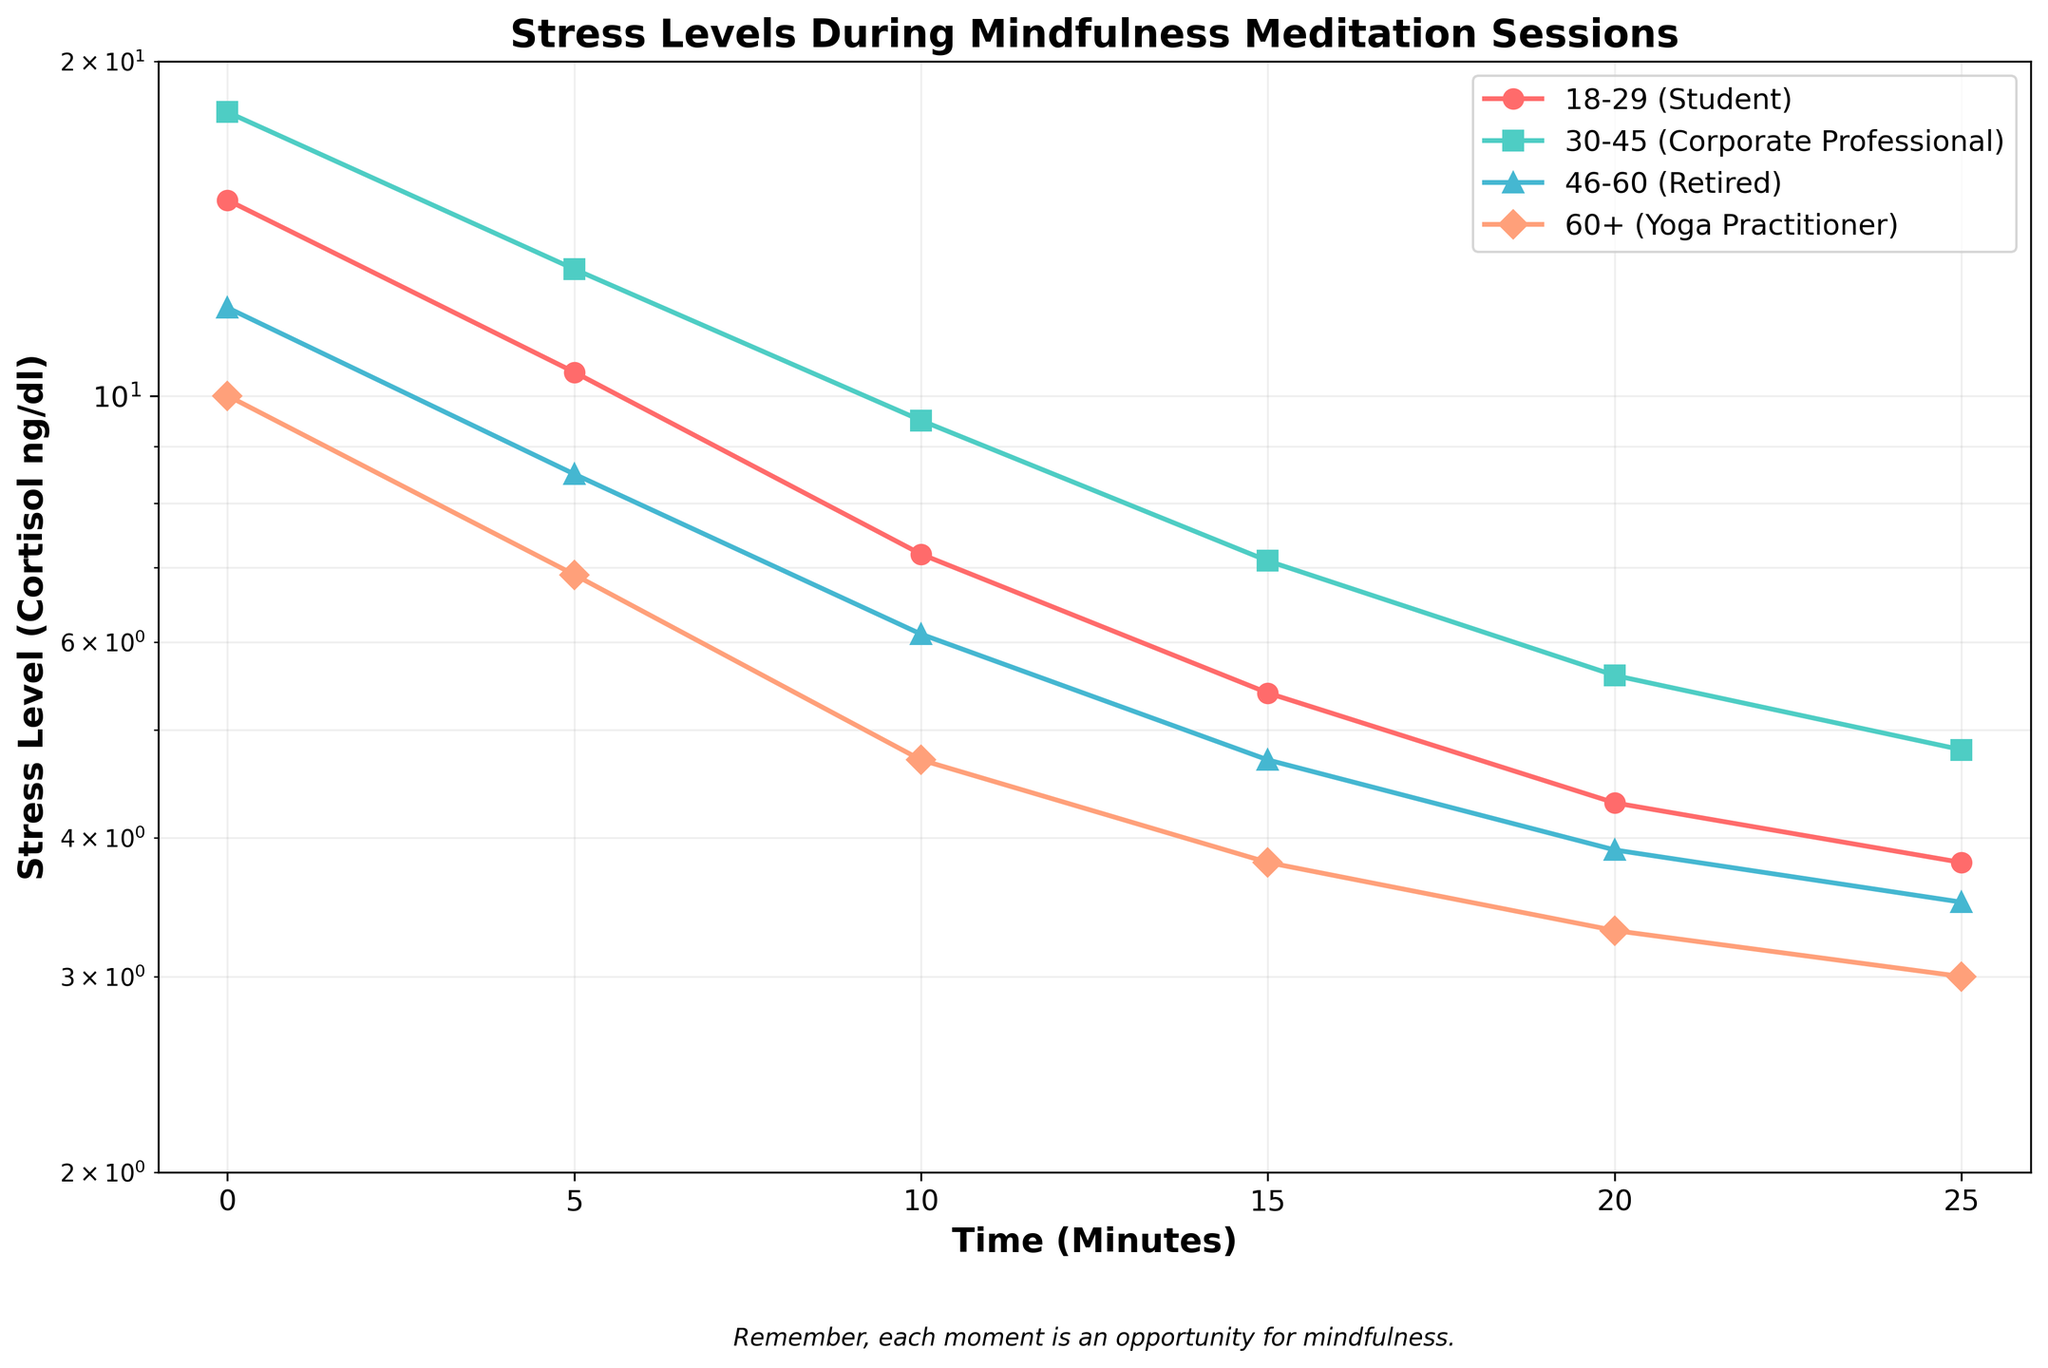What is the title of the plot? The title is prominently displayed at the top of the plot, indicating the subject of the visualization.
Answer: Stress Levels During Mindfulness Meditation Sessions Which age group experiences the lowest initial stress level? The initial stress level for each age group is found at the 0-minute mark on the x-axis. By comparing these values, we see that the "60+ (Yoga Practitioner)" group starts with the lowest stress level.
Answer: 60+ (Yoga Practitioner) By how much does the stress level of the '18-29 Student' group decrease from 0 to 25 minutes? To find this, subtract the stress level at 25 minutes from the stress level at 0 minutes for the '18-29 Student' group: 15.0 - 3.8.
Answer: 11.2 Which group shows the steepest decline in stress levels between 0 to 10 minutes? The steepest decline is indicated by the steepest slope on the plot between 0 and 10 minutes. For each group, observe the difference between stress levels at 0 and 10 minutes. The '30-45 Corporate Professional' group has the steepest decline from 18.0 to 9.5.
Answer: 30-45 Corporate Professional At the 15-minute mark, which group has the highest stress level? To determine this, locate the 15-minute mark on the x-axis and compare the corresponding stress levels of each group. The '30-45 Corporate Professional' group has the highest stress level.
Answer: 30-45 Corporate Professional Between which minutes does the '46-60 Retired' group experience the most significant reduction in stress levels? Examine the plot for the '46-60 Retired' group and determine where the steepest slope occurs by comparing minute intervals. The most significant reduction is between 0 to 5 minutes, from 12.0 to 8.5.
Answer: 0 to 5 minutes How does the final stress level of the '60+ Yoga Practitioner' group compare to that of the '18-29 Student' group? Compare the stress levels at 25 minutes for both groups. The '60+ Yoga Practitioner' group has a final stress level of 3.0 and the '18-29 Student' group has 3.8, making the former group lower.
Answer: 60+ Yoga Practitioner has a lower final stress level Which age group shows the least change in stress levels over the 25-minute session? Compare the difference between the initial and final stress levels of each group. The '60+ Yoga Practitioner' group has the smallest change from 10.0 to 3.0, a difference of 7.0.
Answer: 60+ Yoga Practitioner If you sum the final stress levels of each group, what is the total? Add the final stress levels at 25 minutes for all groups:
3.8 (18-29) + 4.8 (30-45) + 3.5 (46-60) + 3.0 (60+) = 15.1
Answer: 15.1 What can be said about the stress levels in relation to the logarithmic scale used for the y-axis? The logarithmic scale helps visualize the rate of change more clearly, especially for values that span several orders of magnitude. A linear decrease would appear as a curve, emphasizing the reduction rate.
Answer: The log scale highlights the rate of reduction in stress 